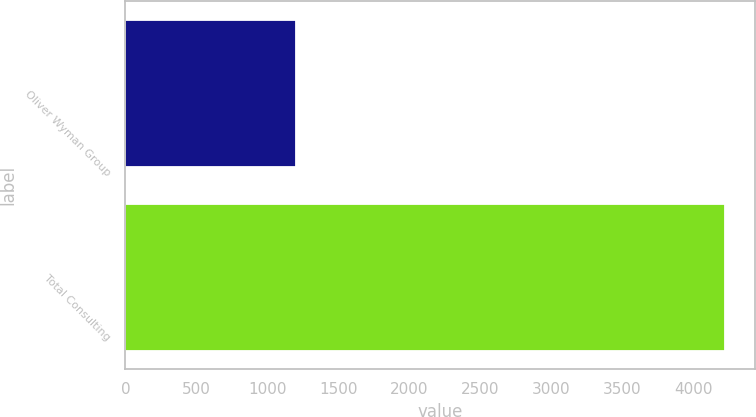Convert chart. <chart><loc_0><loc_0><loc_500><loc_500><bar_chart><fcel>Oliver Wyman Group<fcel>Total Consulting<nl><fcel>1204<fcel>4225<nl></chart> 